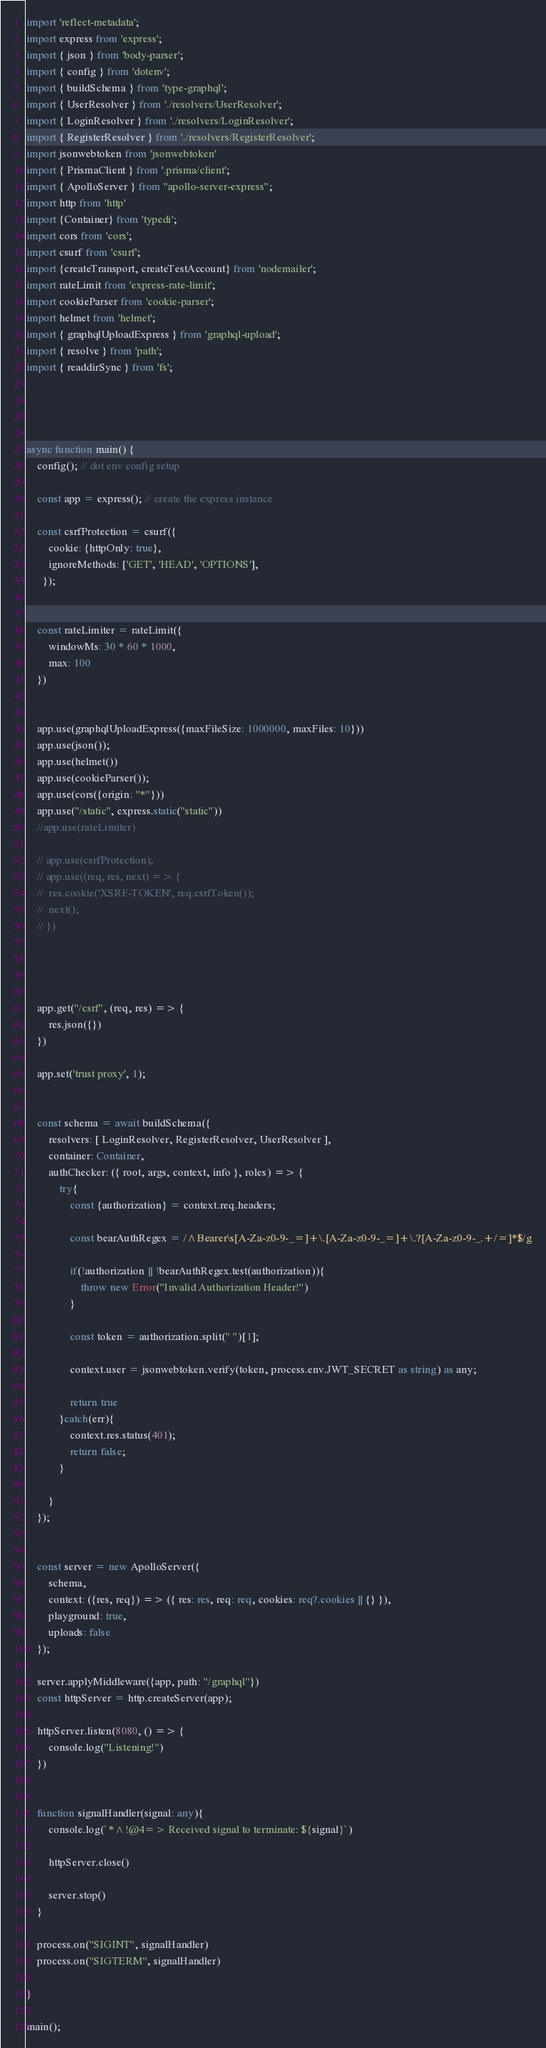<code> <loc_0><loc_0><loc_500><loc_500><_TypeScript_>import 'reflect-metadata';
import express from 'express';
import { json } from 'body-parser';
import { config } from 'dotenv';
import { buildSchema } from 'type-graphql';
import { UserResolver } from './resolvers/UserResolver';
import { LoginResolver } from './resolvers/LoginResolver';
import { RegisterResolver } from './resolvers/RegisterResolver';
import jsonwebtoken from 'jsonwebtoken'
import { PrismaClient } from '.prisma/client';
import { ApolloServer } from "apollo-server-express";
import http from 'http'
import {Container} from 'typedi';
import cors from 'cors';
import csurf from 'csurf';
import {createTransport, createTestAccount} from 'nodemailer';
import rateLimit from 'express-rate-limit';
import cookieParser from 'cookie-parser';
import helmet from 'helmet';
import { graphqlUploadExpress } from 'graphql-upload';
import { resolve } from 'path';
import { readdirSync } from 'fs';




async function main() {
	config(); // dot env config setup

	const app = express(); // create the express instance

	const csrfProtection = csurf({
		cookie: {httpOnly: true},
		ignoreMethods: ['GET', 'HEAD', 'OPTIONS'],
	  });


	const rateLimiter = rateLimit({
		windowMs: 30 * 60 * 1000,
		max: 100
	})


	app.use(graphqlUploadExpress({maxFileSize: 1000000, maxFiles: 10}))
	app.use(json());
	app.use(helmet())
	app.use(cookieParser());
	app.use(cors({origin: "*"}))
	app.use("/static", express.static("static"))
	//app.use(rateLimiter)

	// app.use(csrfProtection);
	// app.use((req, res, next) => {
	// 	res.cookie('XSRF-TOKEN', req.csrfToken());
	// 	next();
	// })




	app.get("/csrf", (req, res) => {
		res.json({})
	})

	app.set('trust proxy', 1);


	const schema = await buildSchema({
		resolvers: [ LoginResolver, RegisterResolver, UserResolver ],
		container: Container,
		authChecker: ({ root, args, context, info }, roles) => {
			try{
				const {authorization} = context.req.headers;

				const bearAuthRegex = /^Bearer\s[A-Za-z0-9-_=]+\.[A-Za-z0-9-_=]+\.?[A-Za-z0-9-_.+/=]*$/g

				if(!authorization || !bearAuthRegex.test(authorization)){
					throw new Error("Invalid Authorization Header!")
				}

				const token = authorization.split(" ")[1]; 

				context.user = jsonwebtoken.verify(token, process.env.JWT_SECRET as string) as any;

				return true
            }catch(err){
				context.res.status(401);
                return false;
            }

		}
	});


	const server = new ApolloServer({
		schema,
		context: ({res, req}) => ({ res: res, req: req, cookies: req?.cookies || {} }),
		playground: true,
		uploads: false
	});

	server.applyMiddleware({app, path: "/graphql"})
	const httpServer = http.createServer(app);

	httpServer.listen(8080, () => {
		console.log("Listening!")		
	})


	function signalHandler(signal: any){
		console.log(`*^!@4=> Received signal to terminate: ${signal}`)

		httpServer.close()

		server.stop()
	}

	process.on("SIGINT", signalHandler)
	process.on("SIGTERM", signalHandler)

}

main();
</code> 